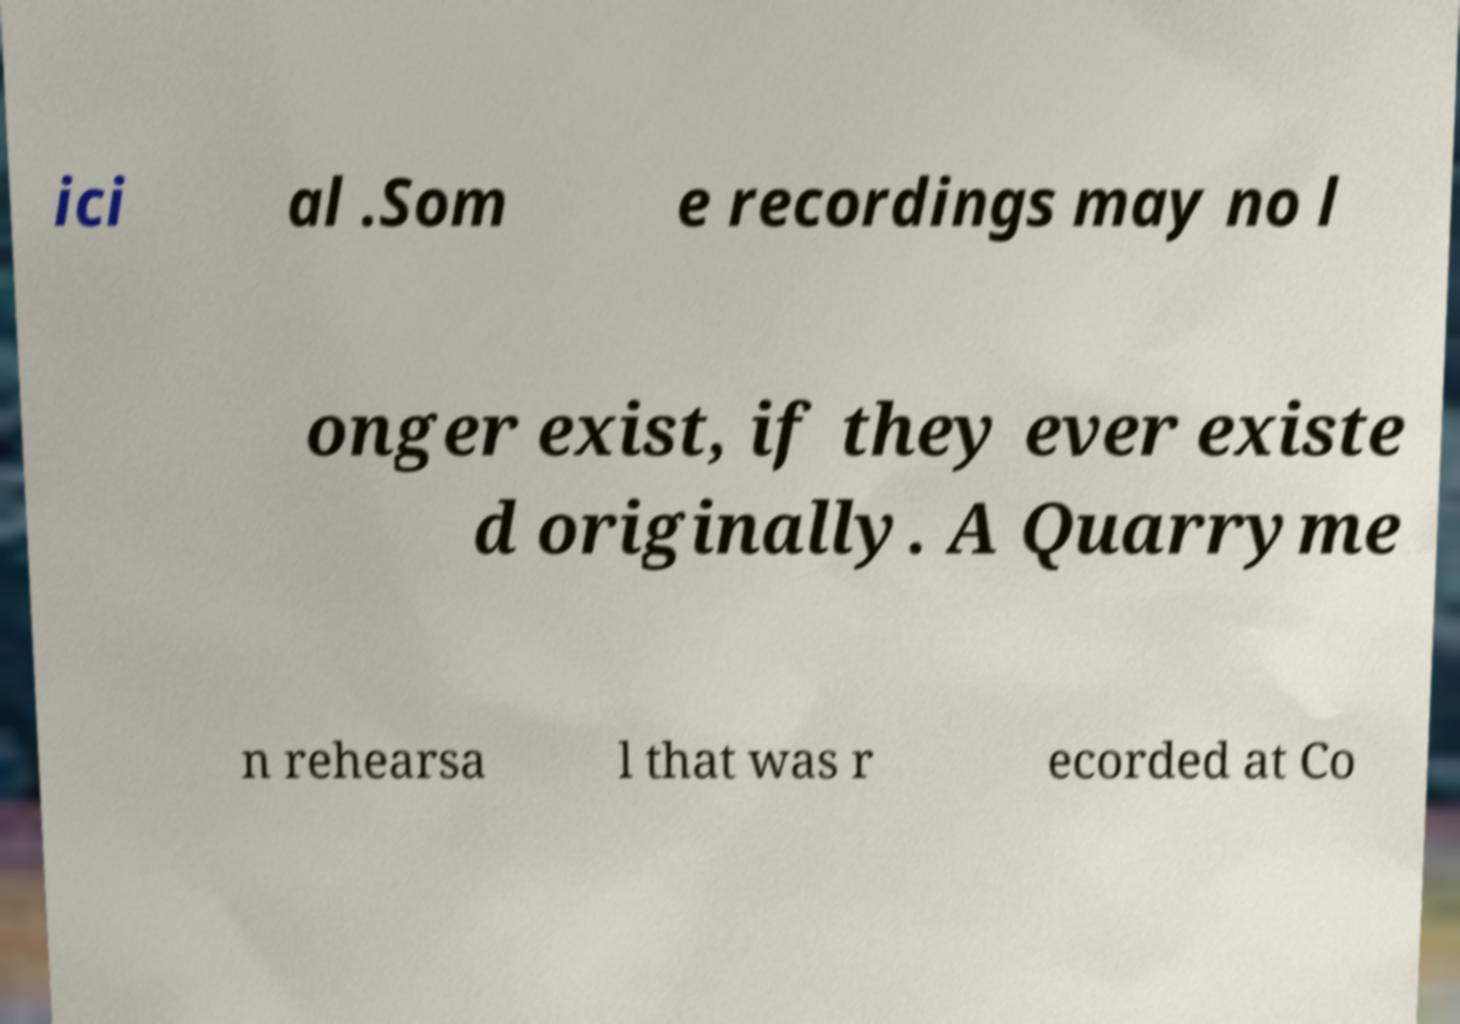There's text embedded in this image that I need extracted. Can you transcribe it verbatim? ici al .Som e recordings may no l onger exist, if they ever existe d originally. A Quarryme n rehearsa l that was r ecorded at Co 